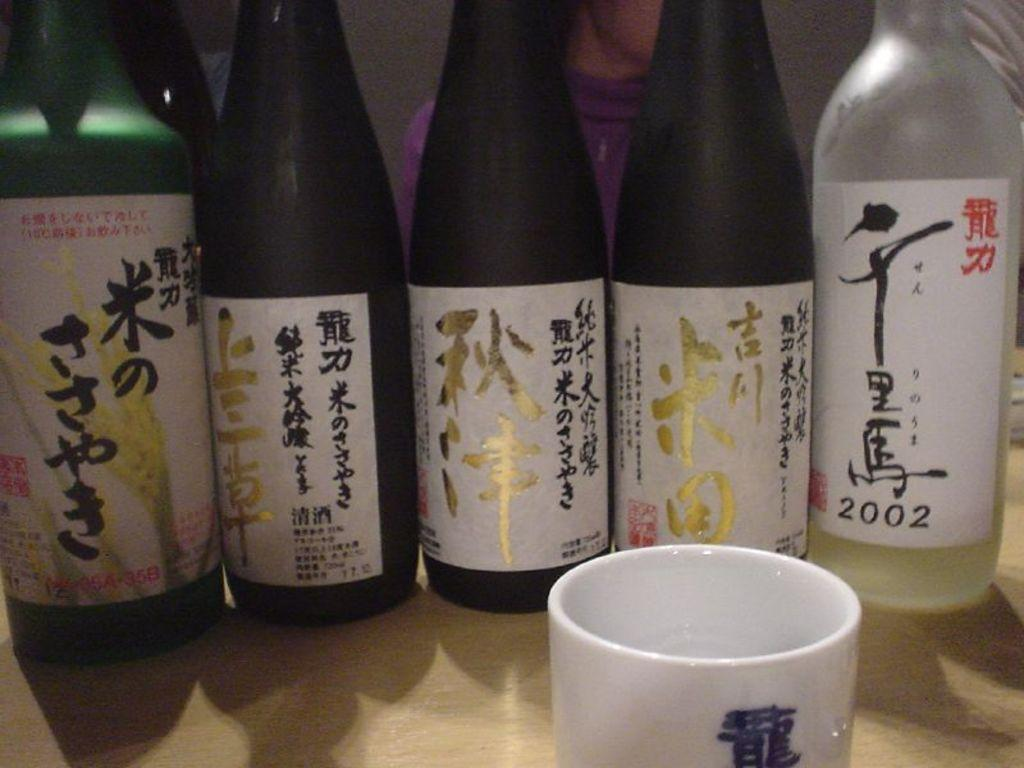Provide a one-sentence caption for the provided image. Five bottles with Chinese characters on them sit in a line, one of the dates reads 2002. 